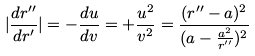Convert formula to latex. <formula><loc_0><loc_0><loc_500><loc_500>| \frac { d r ^ { \prime \prime } } { d r ^ { \prime } } | = - \frac { d u } { d v } = + \frac { u ^ { 2 } } { v ^ { 2 } } = \frac { ( r ^ { \prime \prime } - a ) ^ { 2 } } { ( a - \frac { a ^ { 2 } } { r ^ { \prime \prime } } ) ^ { 2 } }</formula> 